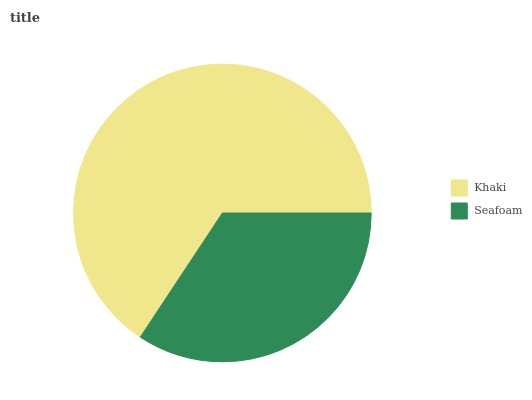Is Seafoam the minimum?
Answer yes or no. Yes. Is Khaki the maximum?
Answer yes or no. Yes. Is Seafoam the maximum?
Answer yes or no. No. Is Khaki greater than Seafoam?
Answer yes or no. Yes. Is Seafoam less than Khaki?
Answer yes or no. Yes. Is Seafoam greater than Khaki?
Answer yes or no. No. Is Khaki less than Seafoam?
Answer yes or no. No. Is Khaki the high median?
Answer yes or no. Yes. Is Seafoam the low median?
Answer yes or no. Yes. Is Seafoam the high median?
Answer yes or no. No. Is Khaki the low median?
Answer yes or no. No. 